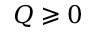<formula> <loc_0><loc_0><loc_500><loc_500>Q \geqslant 0</formula> 